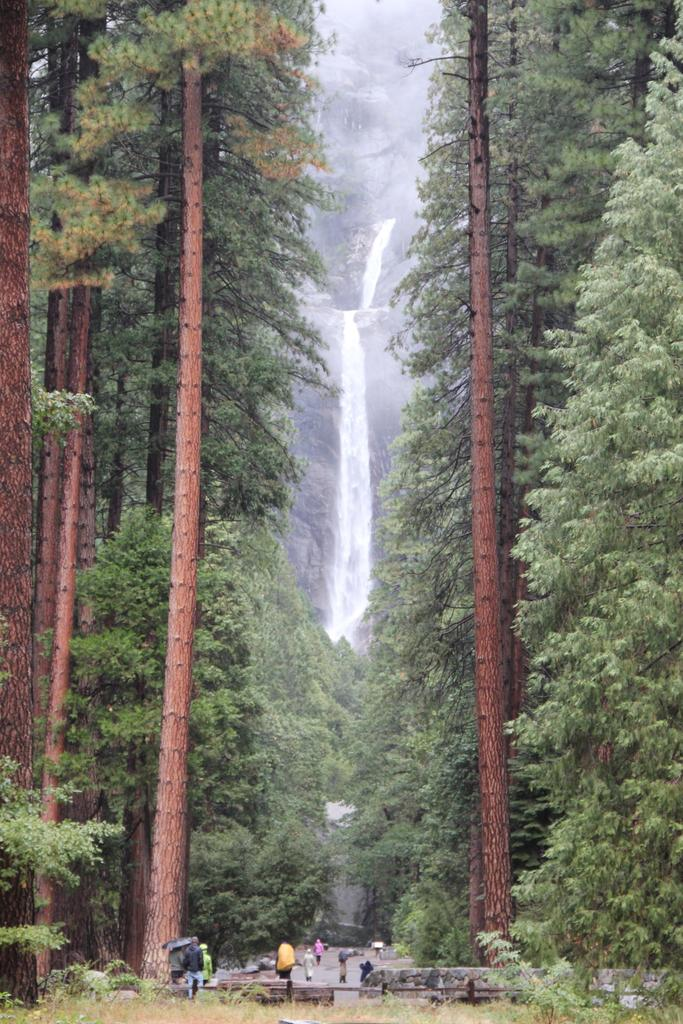What type of natural feature can be seen in the image? There are trees and a waterfall in the image. What is the condition of the ground in the image? Grass is visible in the image. What are the people in the image doing? There are people on the road in the image. What might be used for protection from the elements in the image? Umbrellas are present in the image. What type of gun can be seen in the image? There is no gun present in the image. How many toes are visible on the people in the image? It is impossible to determine the number of toes visible on the people in the image, as their feet are not shown. --- Facts: 1. There is a car in the image. 2. The car is red. 3. The car has four wheels. 4. There are people in the car. 5. The car is parked on the street. Absurd Topics: bird, mountain, book Conversation: What type of vehicle is in the image? There is a car in the image. What color is the car? The car is red. How many wheels does the car have? The car has four wheels. Who is inside the car? There are people in the car. Where is the car located in the image? The car is parked on the street. Reasoning: Let's think step by step in order to produce the conversation. We start by identifying the main subject in the image, which is the car. Then, we describe the car's color and the number of wheels it has. Next, we mention the presence of people inside the car. Finally, we describe the car's location, which is parked on the street. Absurd Question/Answer: What type of bird can be seen perched on the car in the image? There is no bird present on the car in the image. What type of book is visible on the dashboard of the car in the image? There is no book visible on the dashboard of the car in the image. 